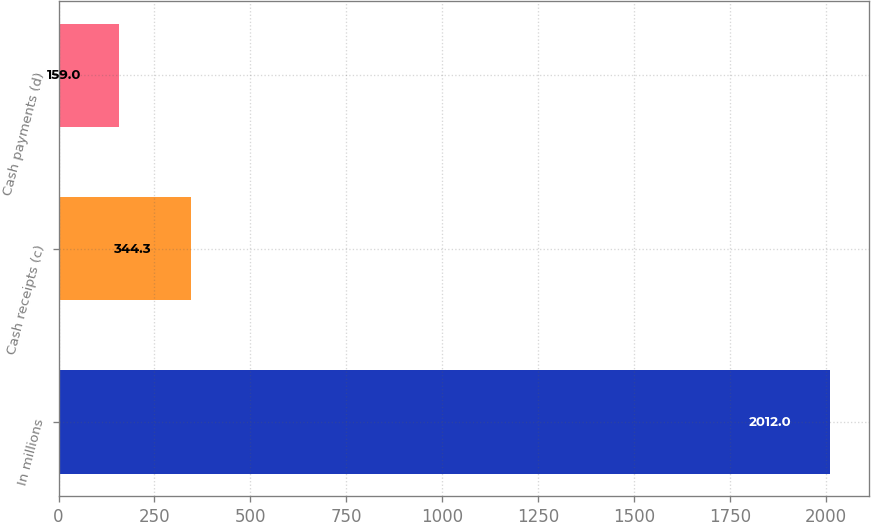Convert chart to OTSL. <chart><loc_0><loc_0><loc_500><loc_500><bar_chart><fcel>In millions<fcel>Cash receipts (c)<fcel>Cash payments (d)<nl><fcel>2012<fcel>344.3<fcel>159<nl></chart> 